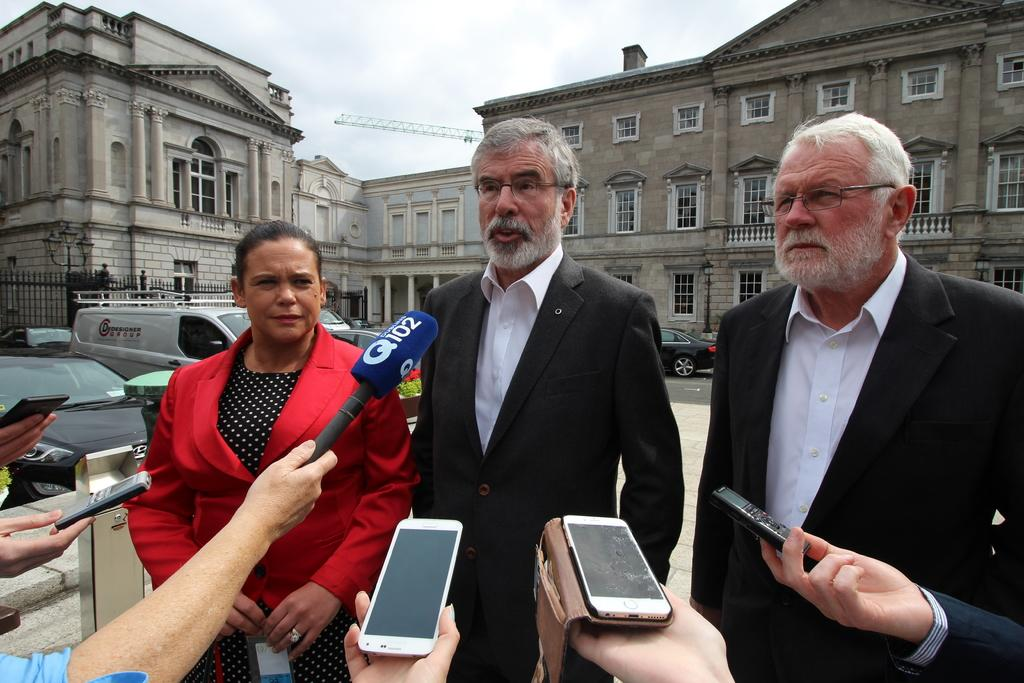<image>
Present a compact description of the photo's key features. a man talking to the mic which says Q102 on it 